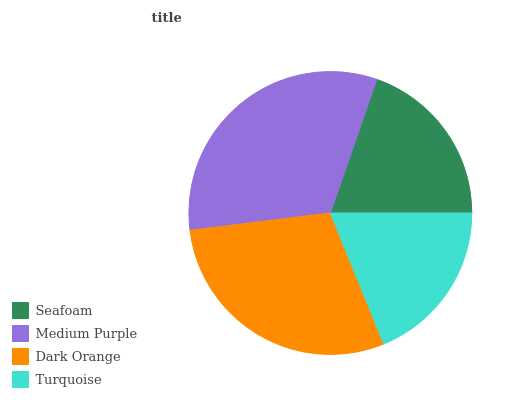Is Turquoise the minimum?
Answer yes or no. Yes. Is Medium Purple the maximum?
Answer yes or no. Yes. Is Dark Orange the minimum?
Answer yes or no. No. Is Dark Orange the maximum?
Answer yes or no. No. Is Medium Purple greater than Dark Orange?
Answer yes or no. Yes. Is Dark Orange less than Medium Purple?
Answer yes or no. Yes. Is Dark Orange greater than Medium Purple?
Answer yes or no. No. Is Medium Purple less than Dark Orange?
Answer yes or no. No. Is Dark Orange the high median?
Answer yes or no. Yes. Is Seafoam the low median?
Answer yes or no. Yes. Is Turquoise the high median?
Answer yes or no. No. Is Turquoise the low median?
Answer yes or no. No. 